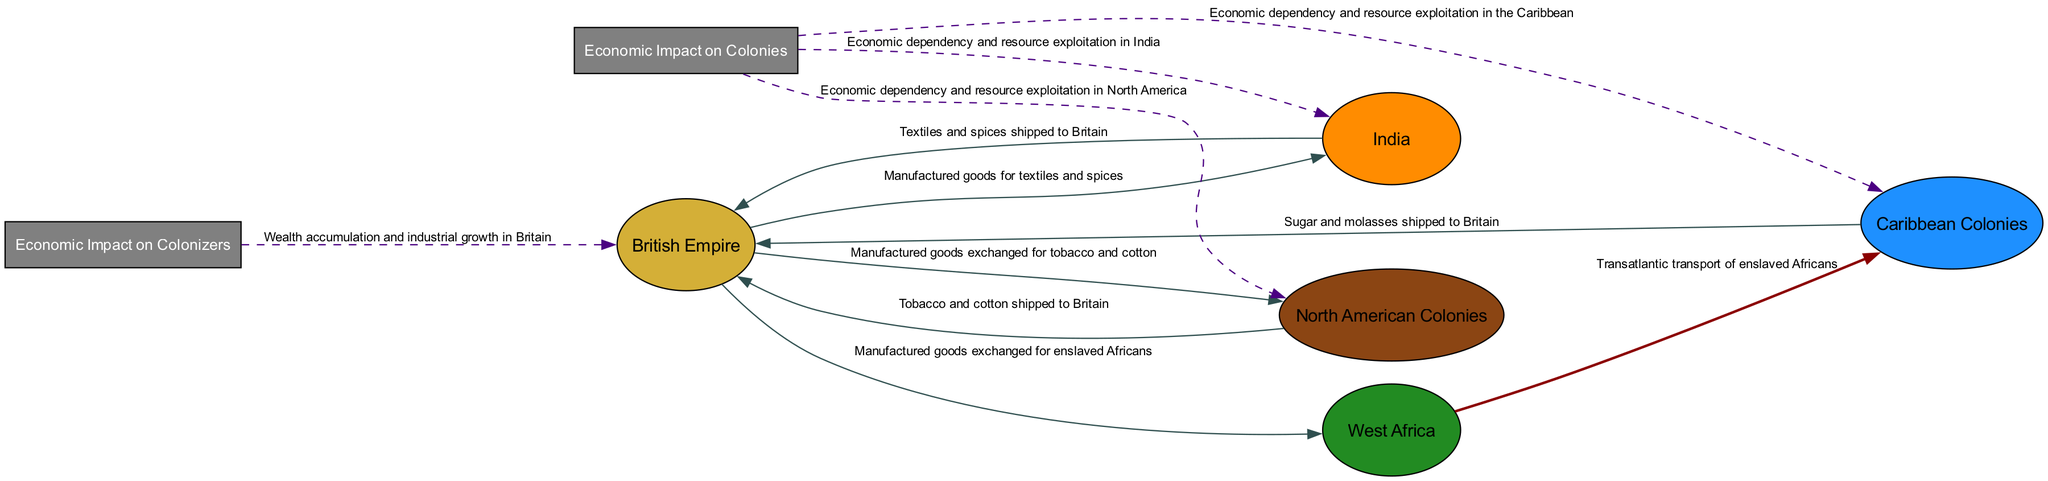What are the key goods traded from the Caribbean Colonies? The diagram indicates that the Caribbean Colonies produced sugar and molasses. This information can be found in the description for the Caribbean Colonies node.
Answer: Sugar and molasses How many nodes are there in the diagram? By counting each unique entity in the nodes section of the diagram, I find there are 7 nodes, including both the colonizers and their colonies, as well as the economic impacts.
Answer: 7 What is the economic impact on the British Empire? According to the edges connecting to the British Empire, it is described that there is wealth accumulation and industrial growth. This direct reference is under the Economic Impact on Colonizers node.
Answer: Wealth accumulation and industrial growth Which region is the source of enslaved Africans? The diagram specifies that West Africa is the source of enslaved Africans, indicated in the description of the West Africa node.
Answer: West Africa What goods were exchanged for textiles and spices? Referring to the Trade Route from the British Empire to India, it is stated that manufactured goods were exchanged for textiles and spices, which is explicitly mentioned in the edge description.
Answer: Manufactured goods What type of economic impact did the colonies experience? The diagram outlines that the economic impact on the colonies resulted in economic dependency and resource exploitation, visible in the connections from the Economic Impact on Colonies node.
Answer: Economic dependency and resource exploitation How does the Middle Passage relate to the trade routes? The Middle Passage is specifically noted as the transatlantic transport of enslaved Africans, connecting West Africa to the Caribbean Colonies, which signifies a crucial aspect of the colonial trade routes depicted.
Answer: Transatlantic transport of enslaved Africans What color represents India in the diagram? The diagram uses a dark orange color to represent India, which can be identified in the node's color coding within the diagram.
Answer: Dark orange Which colony was known for producing tobacco and cotton? The North American Colonies node clearly states that it was known for producing tobacco and cotton, making it identifiable through its description.
Answer: North American Colonies 